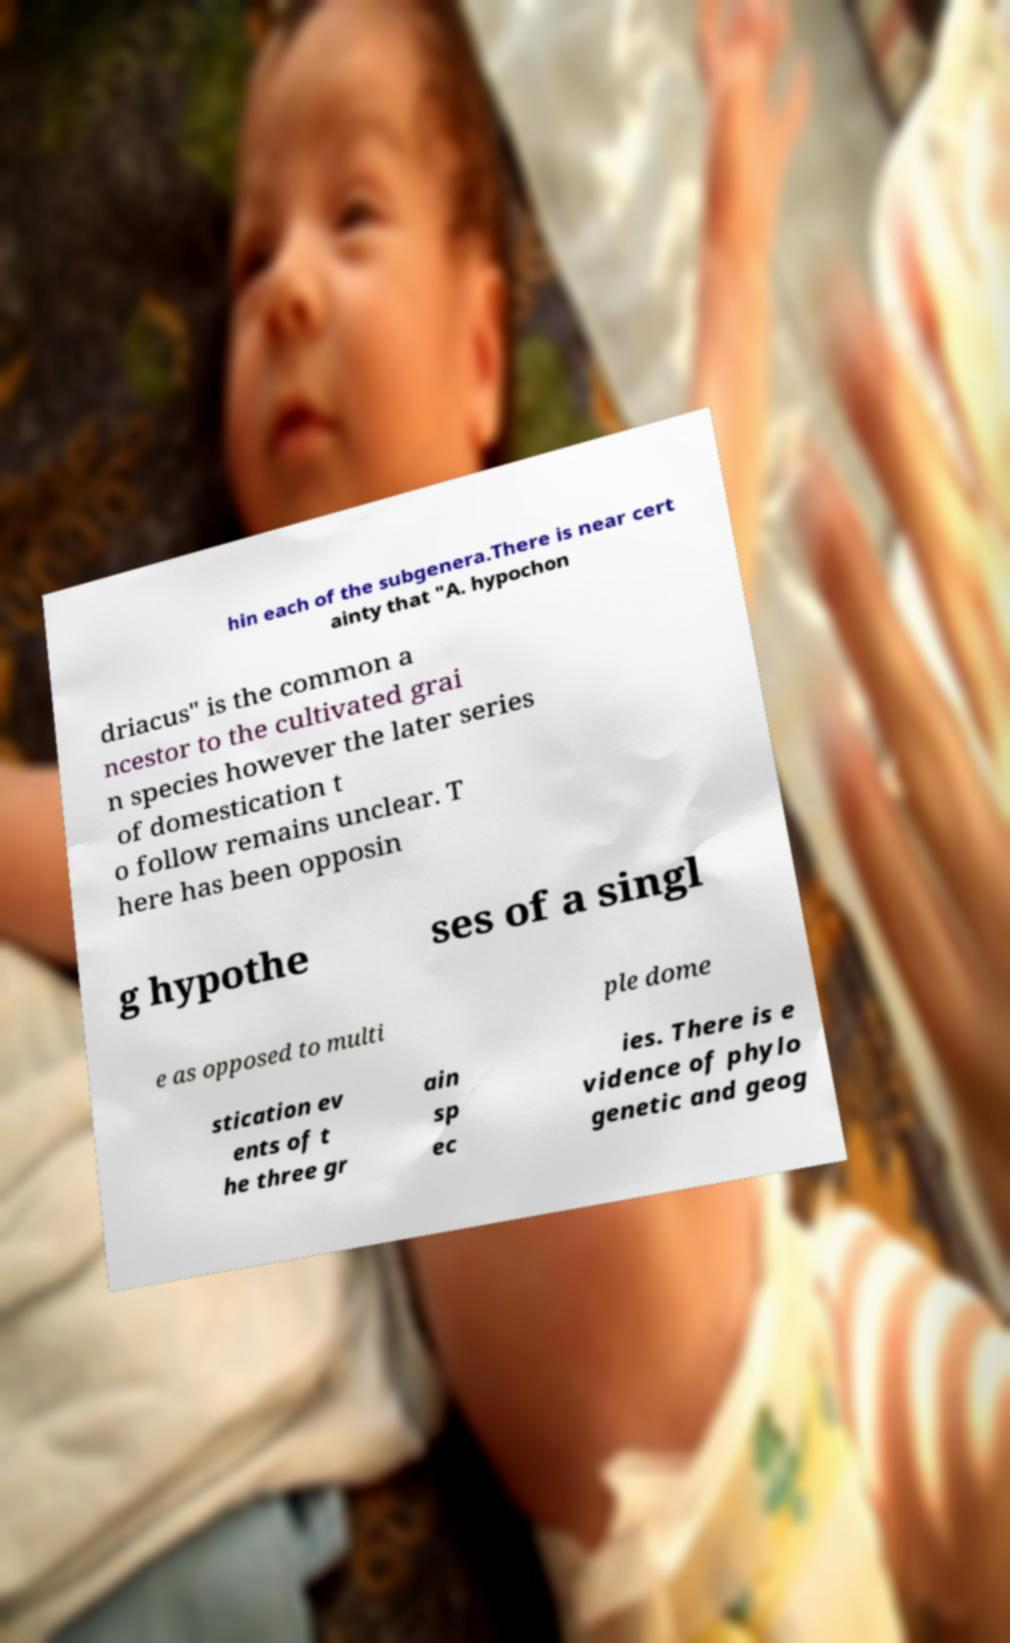For documentation purposes, I need the text within this image transcribed. Could you provide that? hin each of the subgenera.There is near cert ainty that "A. hypochon driacus" is the common a ncestor to the cultivated grai n species however the later series of domestication t o follow remains unclear. T here has been opposin g hypothe ses of a singl e as opposed to multi ple dome stication ev ents of t he three gr ain sp ec ies. There is e vidence of phylo genetic and geog 